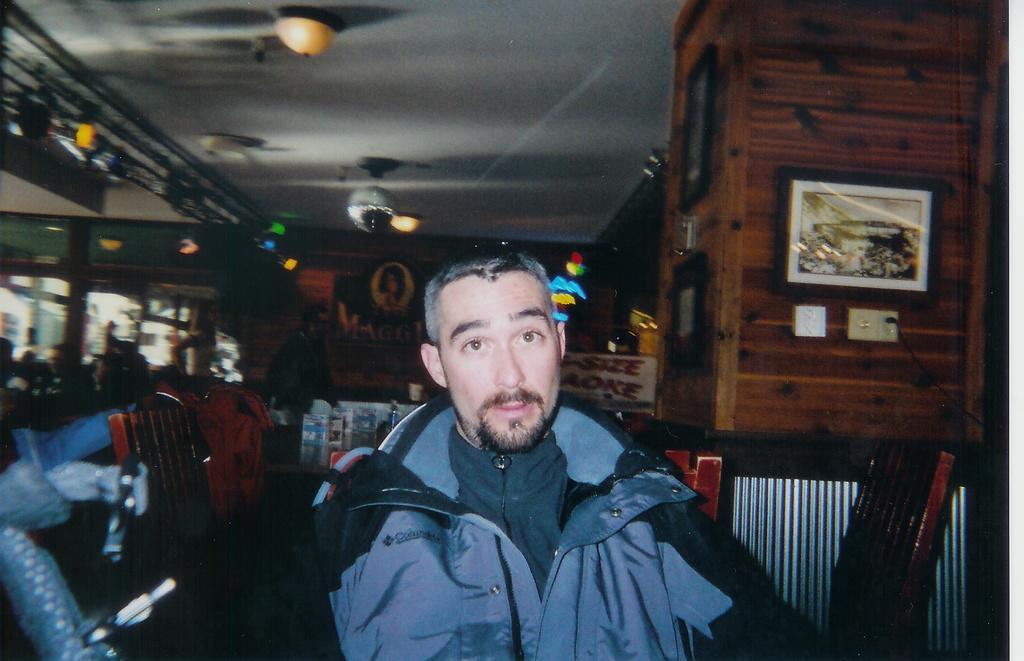Please provide a concise description of this image. In the center of the image we can see a man. In the background we can see the chairs, a frame and switch boards attached to the wooden wall. We can also see the photo frames, glass windows, lights and some text board. At the top we can see the ceiling with the ceiling lights. 